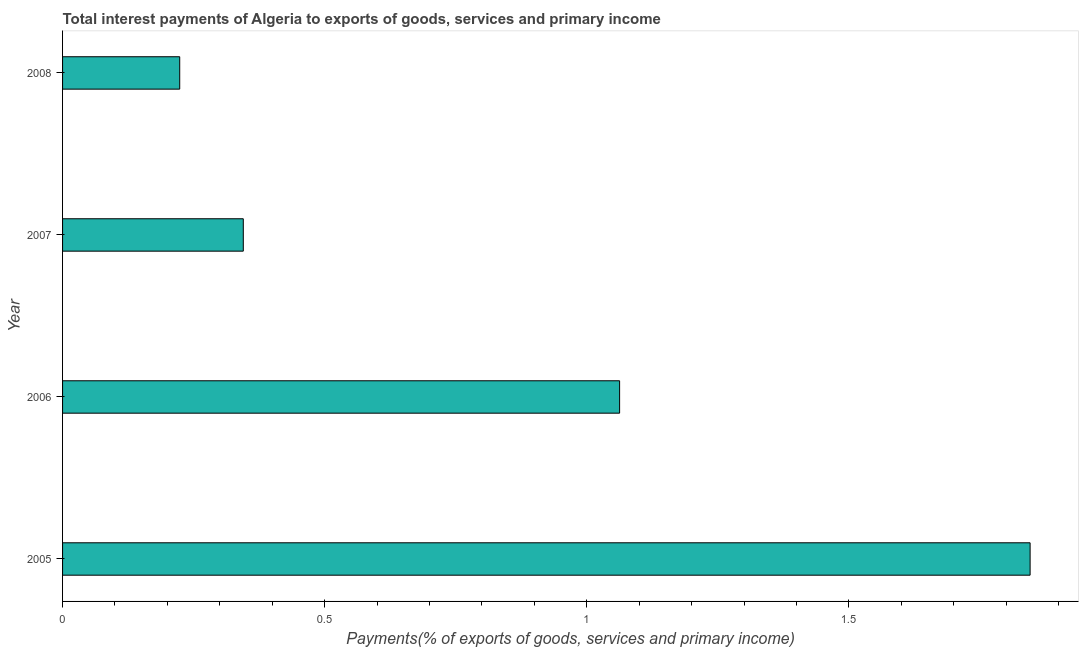Does the graph contain any zero values?
Your answer should be compact. No. What is the title of the graph?
Keep it short and to the point. Total interest payments of Algeria to exports of goods, services and primary income. What is the label or title of the X-axis?
Ensure brevity in your answer.  Payments(% of exports of goods, services and primary income). What is the label or title of the Y-axis?
Provide a short and direct response. Year. What is the total interest payments on external debt in 2006?
Provide a succinct answer. 1.06. Across all years, what is the maximum total interest payments on external debt?
Offer a very short reply. 1.85. Across all years, what is the minimum total interest payments on external debt?
Provide a short and direct response. 0.22. In which year was the total interest payments on external debt maximum?
Your answer should be compact. 2005. In which year was the total interest payments on external debt minimum?
Provide a short and direct response. 2008. What is the sum of the total interest payments on external debt?
Your answer should be compact. 3.48. What is the difference between the total interest payments on external debt in 2006 and 2007?
Give a very brief answer. 0.72. What is the average total interest payments on external debt per year?
Offer a terse response. 0.87. What is the median total interest payments on external debt?
Provide a short and direct response. 0.7. In how many years, is the total interest payments on external debt greater than 1.6 %?
Keep it short and to the point. 1. What is the ratio of the total interest payments on external debt in 2005 to that in 2008?
Provide a succinct answer. 8.26. Is the difference between the total interest payments on external debt in 2005 and 2006 greater than the difference between any two years?
Keep it short and to the point. No. What is the difference between the highest and the second highest total interest payments on external debt?
Provide a succinct answer. 0.78. What is the difference between the highest and the lowest total interest payments on external debt?
Provide a short and direct response. 1.62. What is the Payments(% of exports of goods, services and primary income) of 2005?
Provide a succinct answer. 1.85. What is the Payments(% of exports of goods, services and primary income) in 2006?
Keep it short and to the point. 1.06. What is the Payments(% of exports of goods, services and primary income) of 2007?
Ensure brevity in your answer.  0.34. What is the Payments(% of exports of goods, services and primary income) in 2008?
Keep it short and to the point. 0.22. What is the difference between the Payments(% of exports of goods, services and primary income) in 2005 and 2006?
Offer a terse response. 0.78. What is the difference between the Payments(% of exports of goods, services and primary income) in 2005 and 2007?
Offer a terse response. 1.5. What is the difference between the Payments(% of exports of goods, services and primary income) in 2005 and 2008?
Offer a very short reply. 1.62. What is the difference between the Payments(% of exports of goods, services and primary income) in 2006 and 2007?
Make the answer very short. 0.72. What is the difference between the Payments(% of exports of goods, services and primary income) in 2006 and 2008?
Make the answer very short. 0.84. What is the difference between the Payments(% of exports of goods, services and primary income) in 2007 and 2008?
Your answer should be compact. 0.12. What is the ratio of the Payments(% of exports of goods, services and primary income) in 2005 to that in 2006?
Keep it short and to the point. 1.74. What is the ratio of the Payments(% of exports of goods, services and primary income) in 2005 to that in 2007?
Provide a succinct answer. 5.35. What is the ratio of the Payments(% of exports of goods, services and primary income) in 2005 to that in 2008?
Keep it short and to the point. 8.26. What is the ratio of the Payments(% of exports of goods, services and primary income) in 2006 to that in 2007?
Ensure brevity in your answer.  3.08. What is the ratio of the Payments(% of exports of goods, services and primary income) in 2006 to that in 2008?
Ensure brevity in your answer.  4.75. What is the ratio of the Payments(% of exports of goods, services and primary income) in 2007 to that in 2008?
Your answer should be compact. 1.54. 